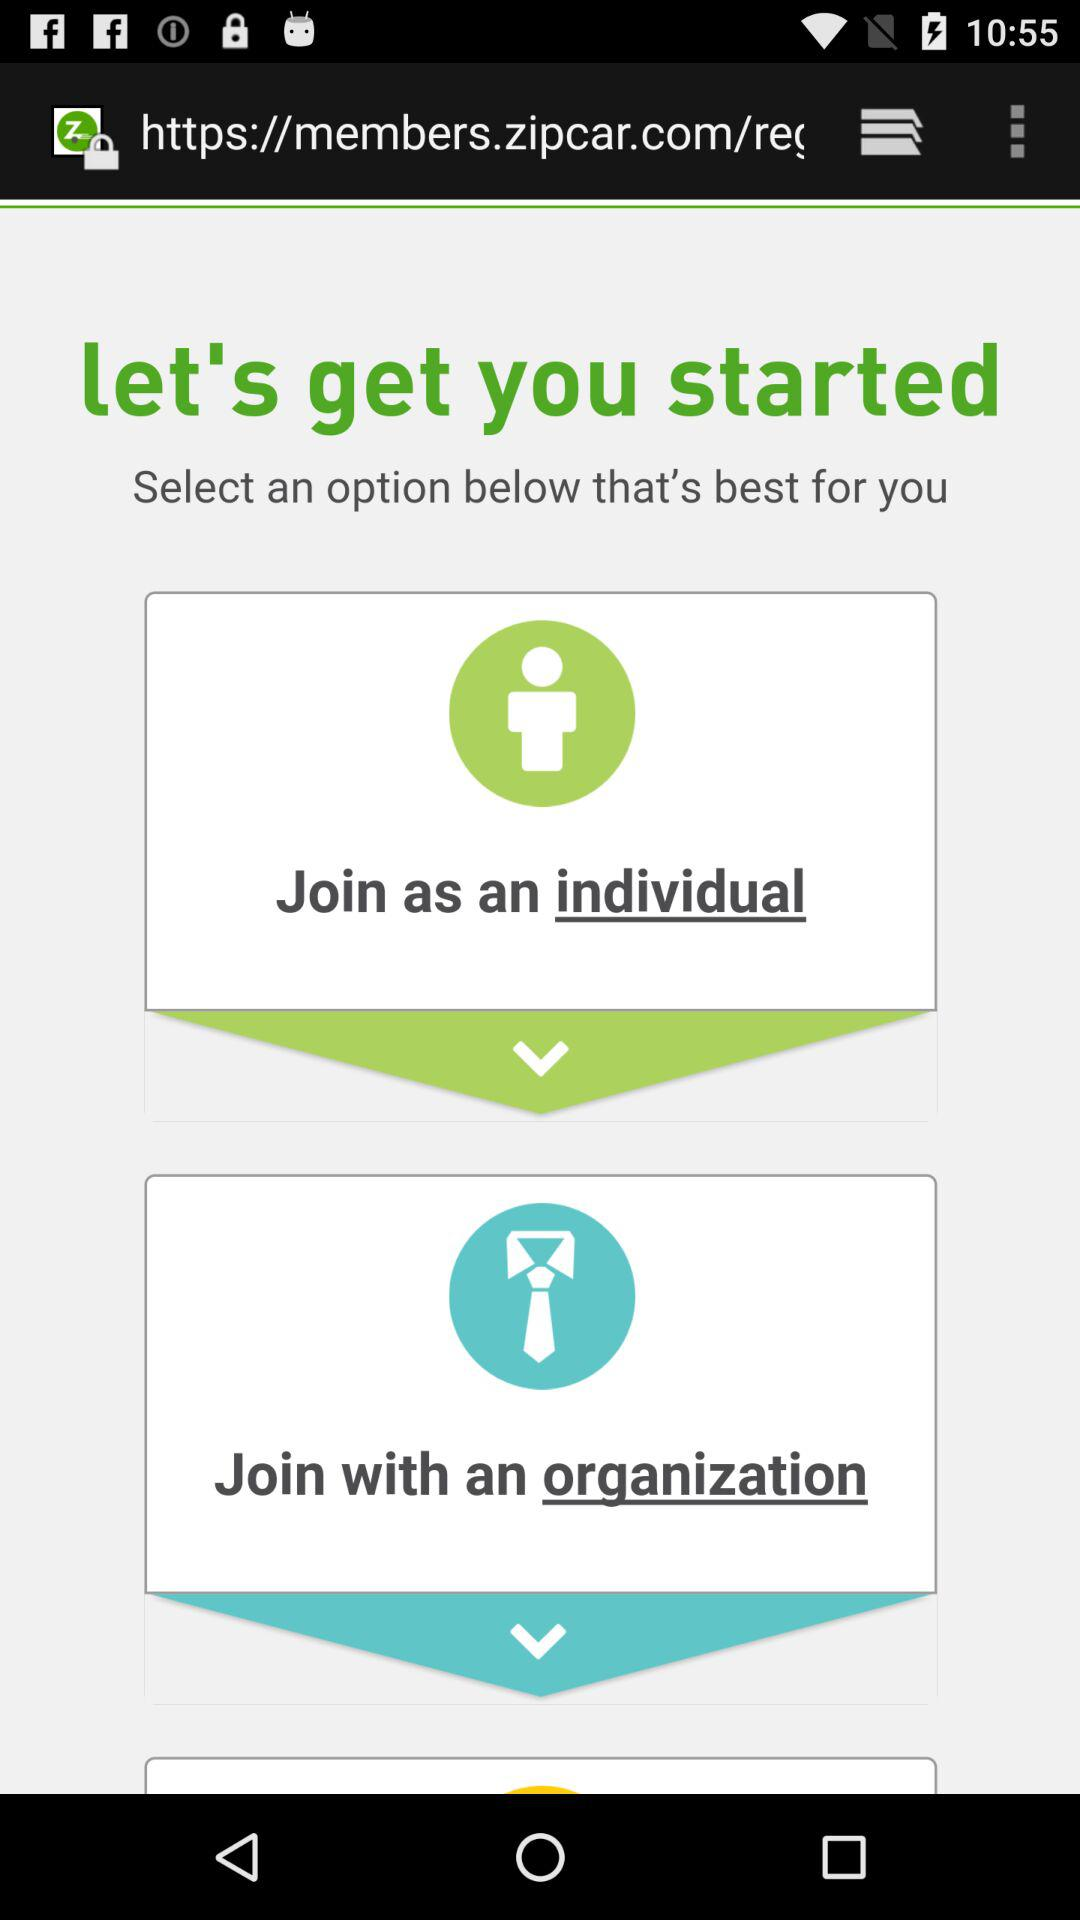What choices are there for me to join? You can join as an individual or join with an organization. 